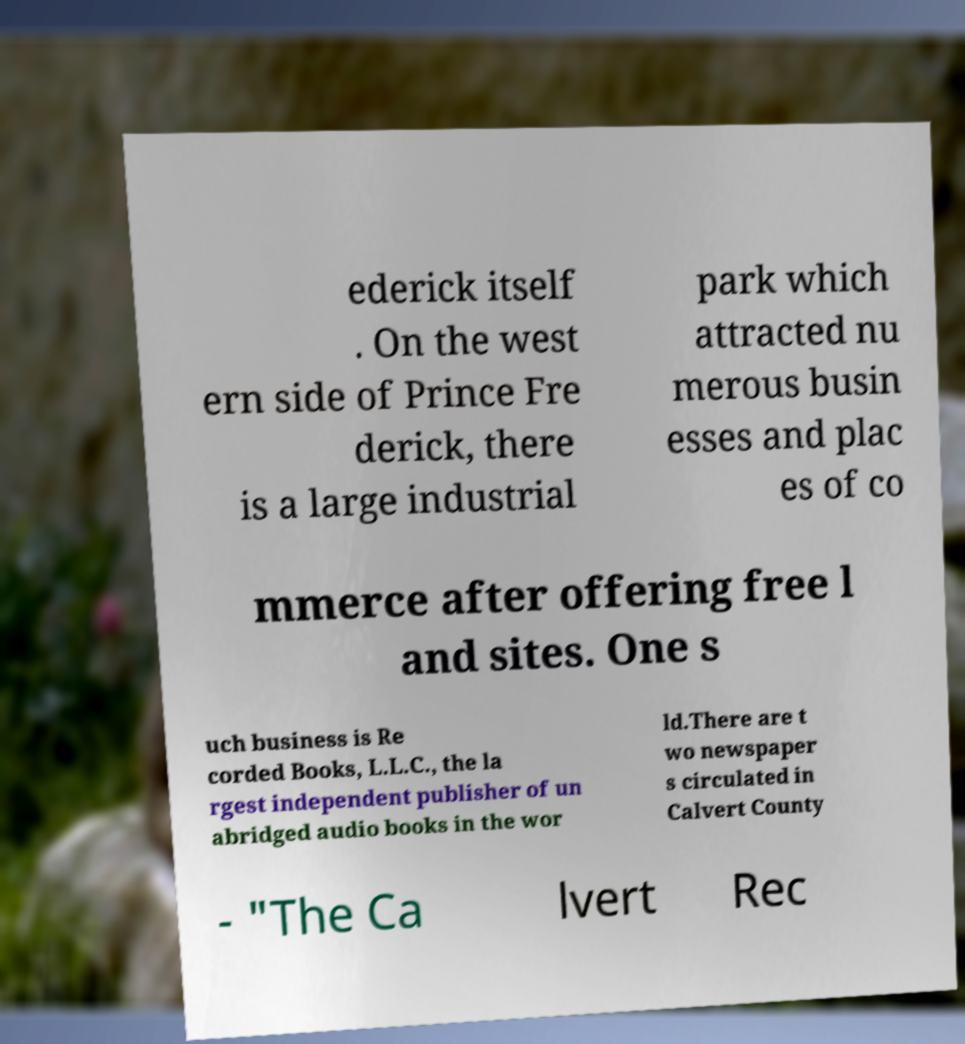Could you extract and type out the text from this image? ederick itself . On the west ern side of Prince Fre derick, there is a large industrial park which attracted nu merous busin esses and plac es of co mmerce after offering free l and sites. One s uch business is Re corded Books, L.L.C., the la rgest independent publisher of un abridged audio books in the wor ld.There are t wo newspaper s circulated in Calvert County - "The Ca lvert Rec 